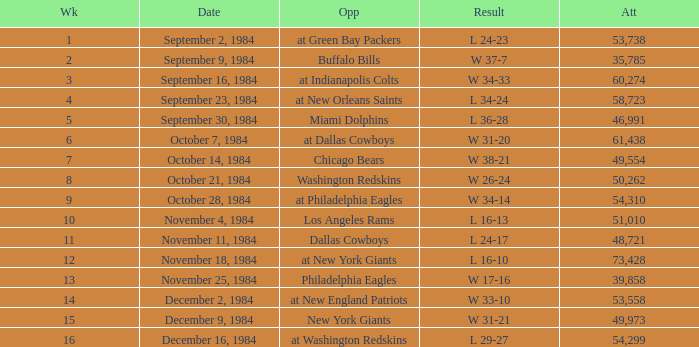What was the result in a week lower than 10 with an opponent of Chicago Bears? W 38-21. 